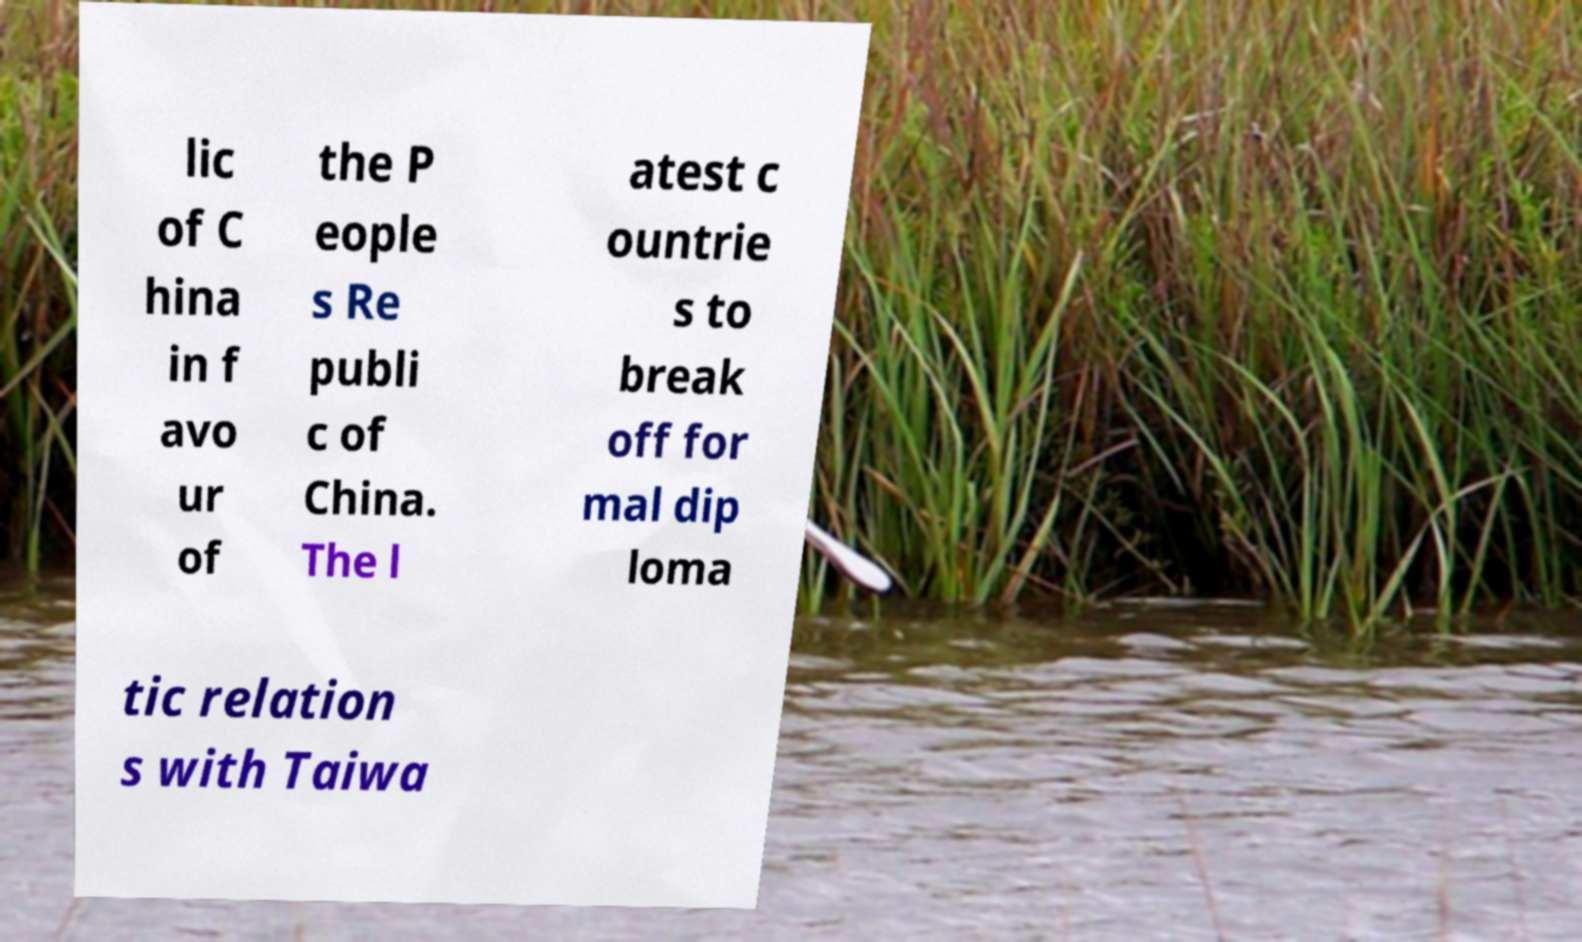For documentation purposes, I need the text within this image transcribed. Could you provide that? lic of C hina in f avo ur of the P eople s Re publi c of China. The l atest c ountrie s to break off for mal dip loma tic relation s with Taiwa 